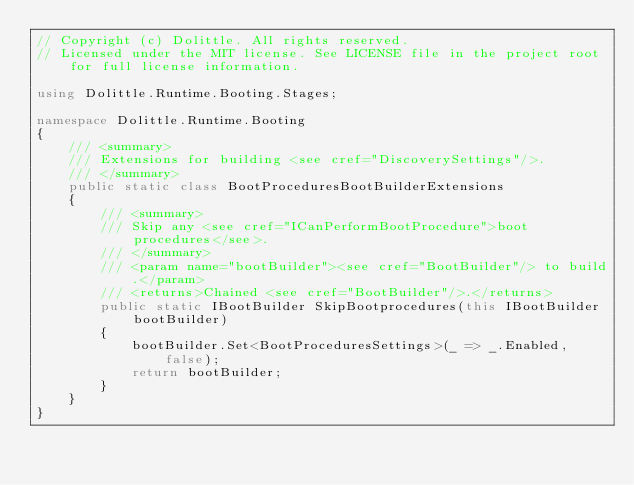Convert code to text. <code><loc_0><loc_0><loc_500><loc_500><_C#_>// Copyright (c) Dolittle. All rights reserved.
// Licensed under the MIT license. See LICENSE file in the project root for full license information.

using Dolittle.Runtime.Booting.Stages;

namespace Dolittle.Runtime.Booting
{
    /// <summary>
    /// Extensions for building <see cref="DiscoverySettings"/>.
    /// </summary>
    public static class BootProceduresBootBuilderExtensions
    {
        /// <summary>
        /// Skip any <see cref="ICanPerformBootProcedure">boot procedures</see>.
        /// </summary>
        /// <param name="bootBuilder"><see cref="BootBuilder"/> to build.</param>
        /// <returns>Chained <see cref="BootBuilder"/>.</returns>
        public static IBootBuilder SkipBootprocedures(this IBootBuilder bootBuilder)
        {
            bootBuilder.Set<BootProceduresSettings>(_ => _.Enabled, false);
            return bootBuilder;
        }
    }
}</code> 